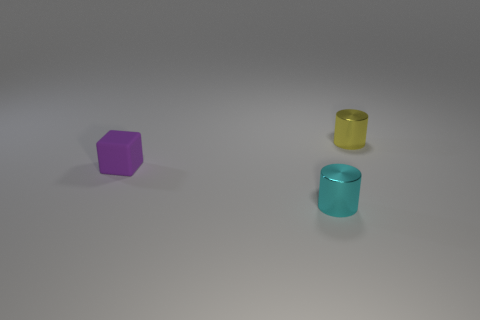Add 1 small yellow cylinders. How many objects exist? 4 Subtract all cylinders. How many objects are left? 1 Add 1 purple cubes. How many purple cubes are left? 2 Add 3 cyan metallic cylinders. How many cyan metallic cylinders exist? 4 Subtract 0 red cubes. How many objects are left? 3 Subtract all large yellow cubes. Subtract all cyan cylinders. How many objects are left? 2 